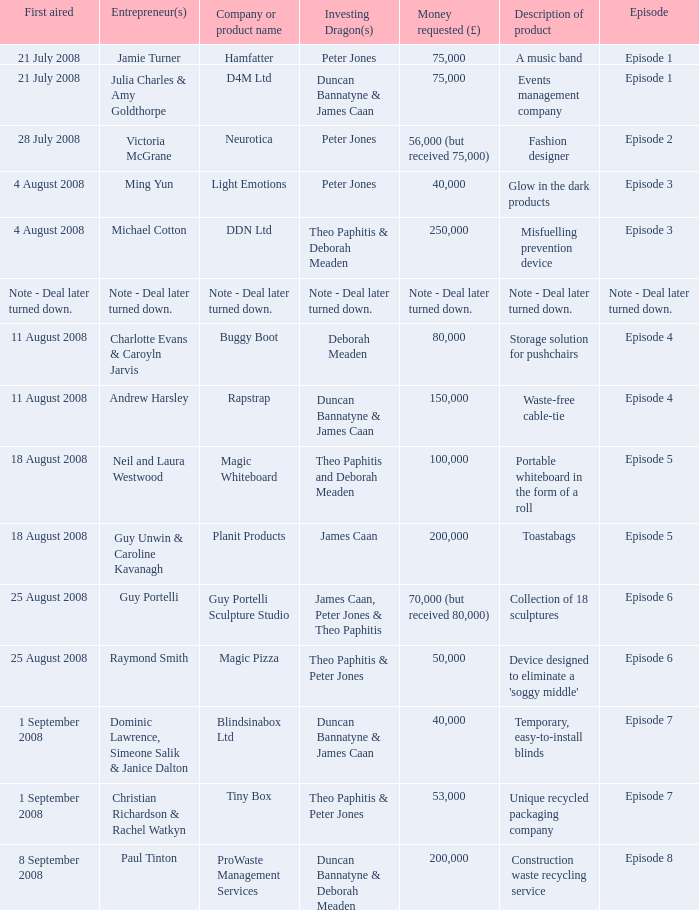Who is the company Investing Dragons, or tiny box? Theo Paphitis & Peter Jones. 